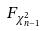Convert formula to latex. <formula><loc_0><loc_0><loc_500><loc_500>F _ { \chi _ { n - 1 } ^ { 2 } }</formula> 